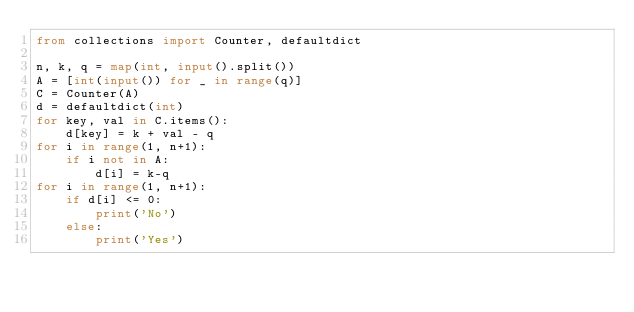<code> <loc_0><loc_0><loc_500><loc_500><_Python_>from collections import Counter, defaultdict

n, k, q = map(int, input().split())
A = [int(input()) for _ in range(q)]
C = Counter(A)
d = defaultdict(int)
for key, val in C.items():
    d[key] = k + val - q
for i in range(1, n+1):
    if i not in A:
        d[i] = k-q
for i in range(1, n+1):
    if d[i] <= 0:
        print('No')
    else:
        print('Yes')
</code> 